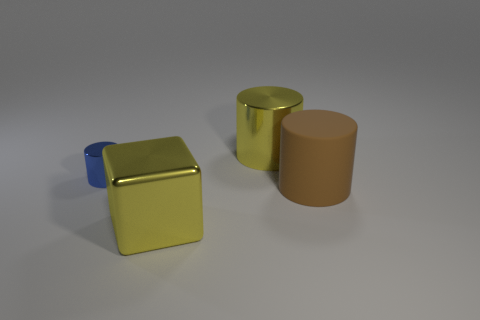Add 2 blue shiny spheres. How many objects exist? 6 Subtract all cylinders. How many objects are left? 1 Subtract all big brown rubber cylinders. Subtract all yellow metal objects. How many objects are left? 1 Add 2 tiny metallic cylinders. How many tiny metallic cylinders are left? 3 Add 2 tiny blue cylinders. How many tiny blue cylinders exist? 3 Subtract 0 red balls. How many objects are left? 4 